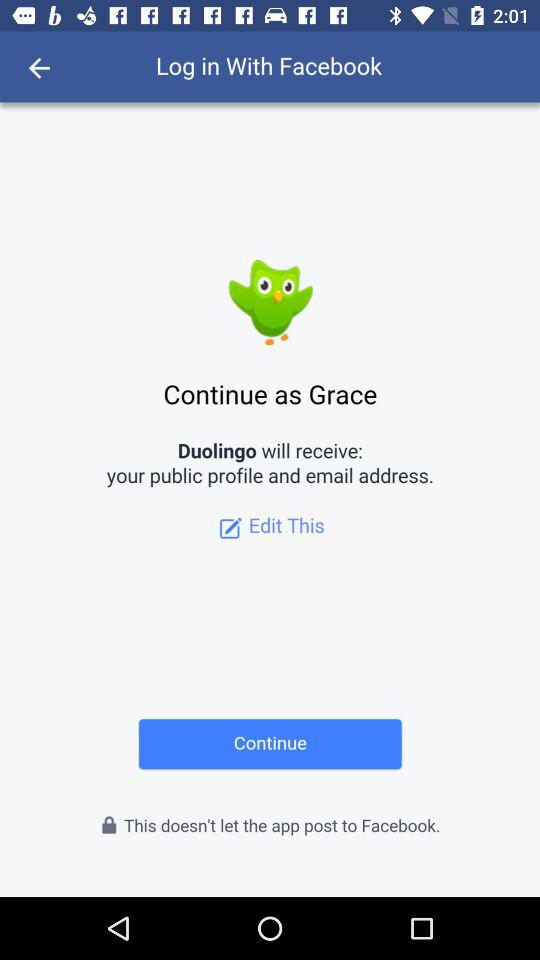What is the name of the user? The name of the user is Grace. 